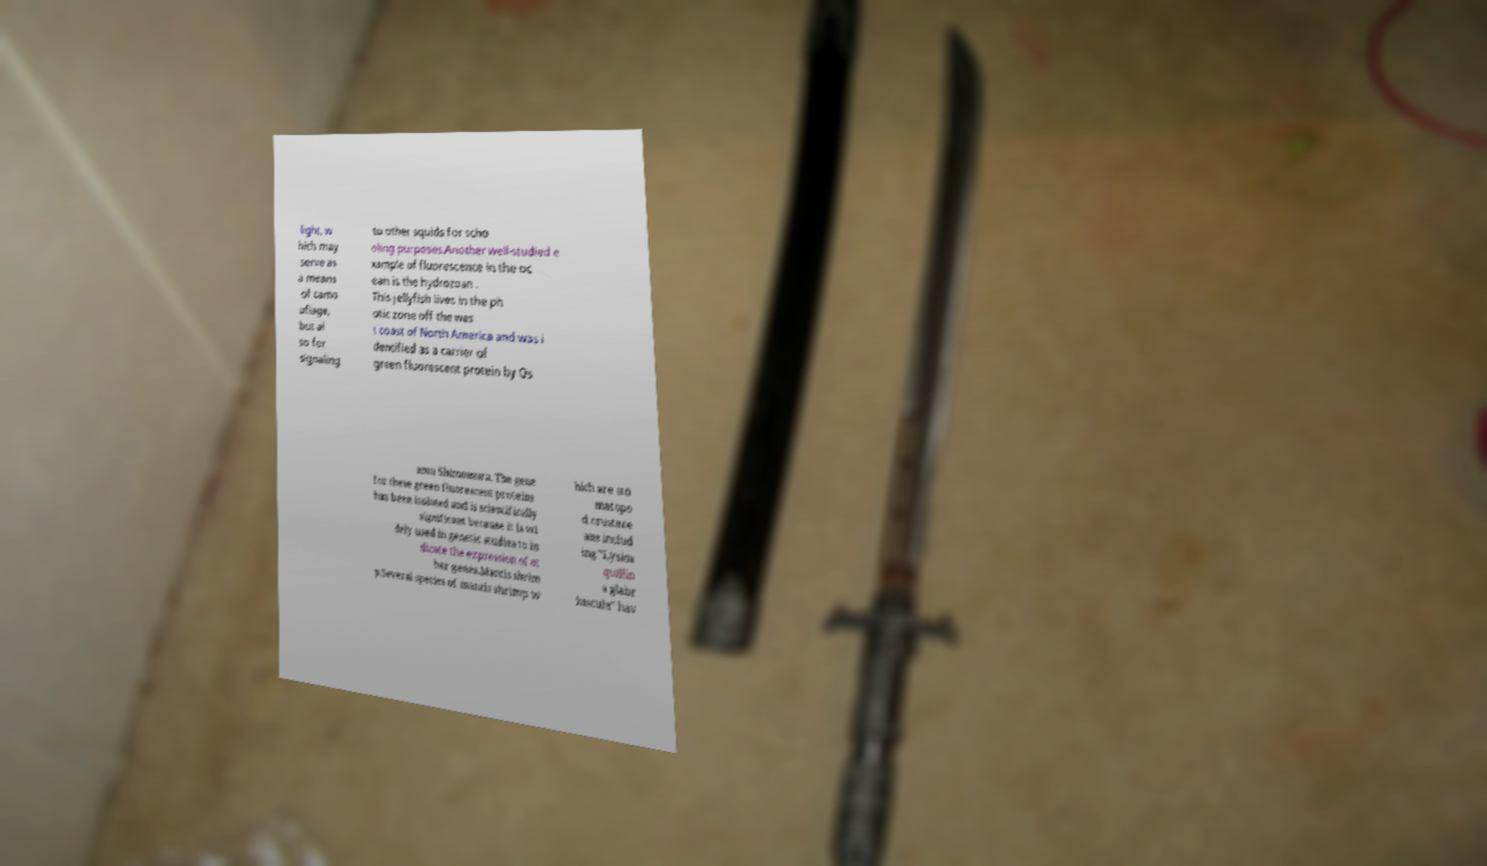For documentation purposes, I need the text within this image transcribed. Could you provide that? light, w hich may serve as a means of camo uflage, but al so for signaling to other squids for scho oling purposes.Another well-studied e xample of fluorescence in the oc ean is the hydrozoan . This jellyfish lives in the ph otic zone off the wes t coast of North America and was i dentified as a carrier of green fluorescent protein by Os amu Shimomura. The gene for these green fluorescent proteins has been isolated and is scientifically significant because it is wi dely used in genetic studies to in dicate the expression of ot her genes.Mantis shrim p.Several species of mantis shrimp w hich are sto matopo d crustace ans includ ing "Lysios quillin a glabr iuscula" hav 